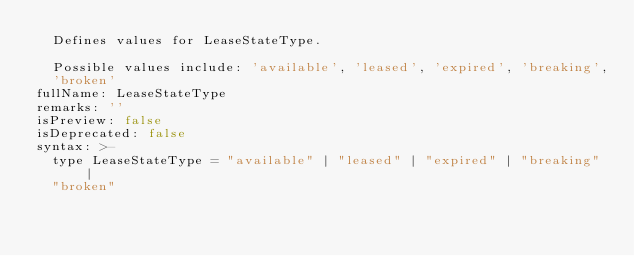Convert code to text. <code><loc_0><loc_0><loc_500><loc_500><_YAML_>  Defines values for LeaseStateType.

  Possible values include: 'available', 'leased', 'expired', 'breaking',
  'broken'
fullName: LeaseStateType
remarks: ''
isPreview: false
isDeprecated: false
syntax: >-
  type LeaseStateType = "available" | "leased" | "expired" | "breaking" |
  "broken"
</code> 